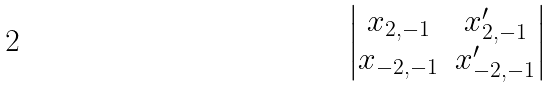Convert formula to latex. <formula><loc_0><loc_0><loc_500><loc_500>\begin{vmatrix} x _ { 2 , - 1 } & x ^ { \prime } _ { 2 , - 1 } \\ x _ { - 2 , - 1 } & x ^ { \prime } _ { - 2 , - 1 } \\ \end{vmatrix}</formula> 